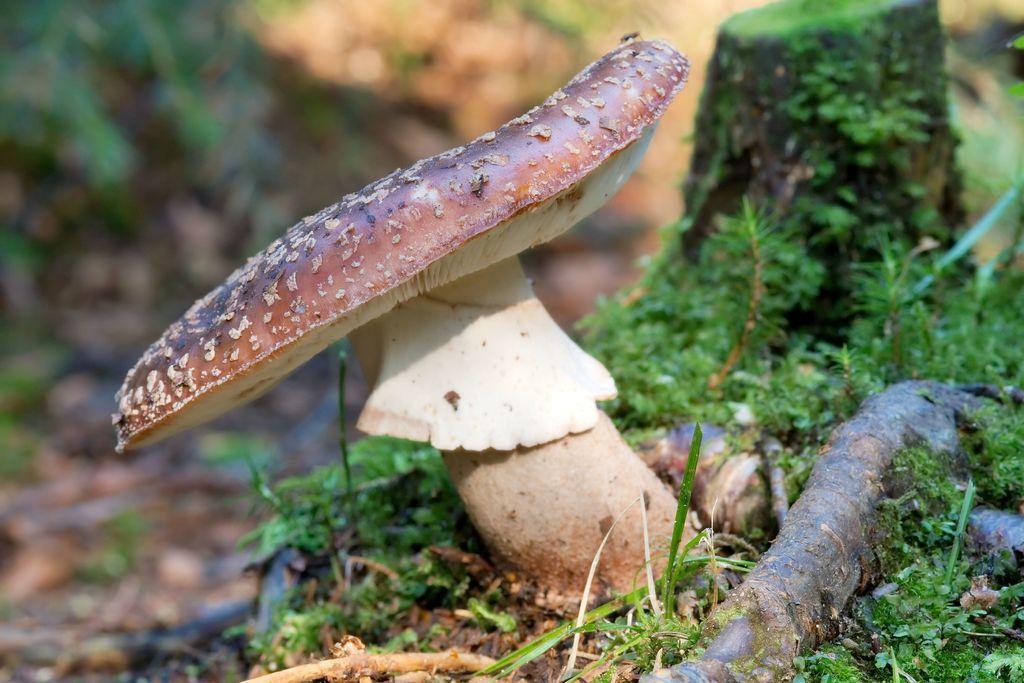In one or two sentences, can you explain what this image depicts? In this image I can see the mushroom, the mushroom is in brown and cream color. Background I can see few plants in green color. 